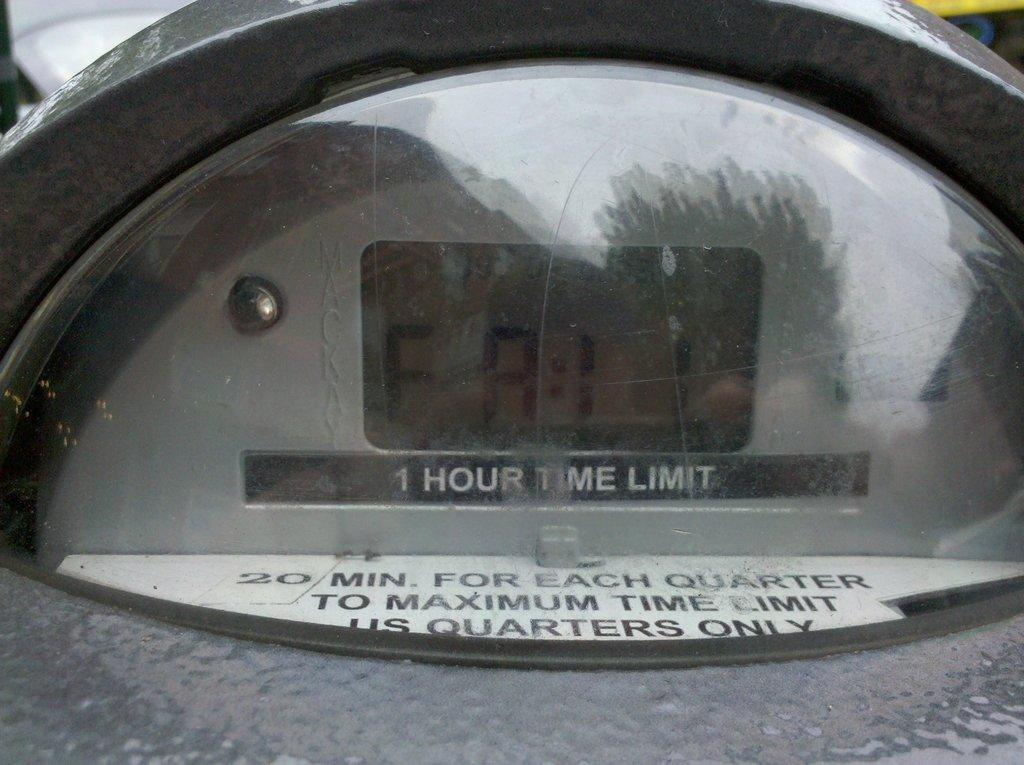Provide a one-sentence caption for the provided image. a glass item that has a 1 hour time limit. 